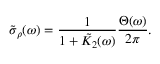Convert formula to latex. <formula><loc_0><loc_0><loc_500><loc_500>\tilde { \sigma } _ { \rho } ( \omega ) = \frac { 1 } { 1 + \tilde { K } _ { 2 } ( \omega ) } \frac { \Theta ( \omega ) } { 2 \pi } .</formula> 